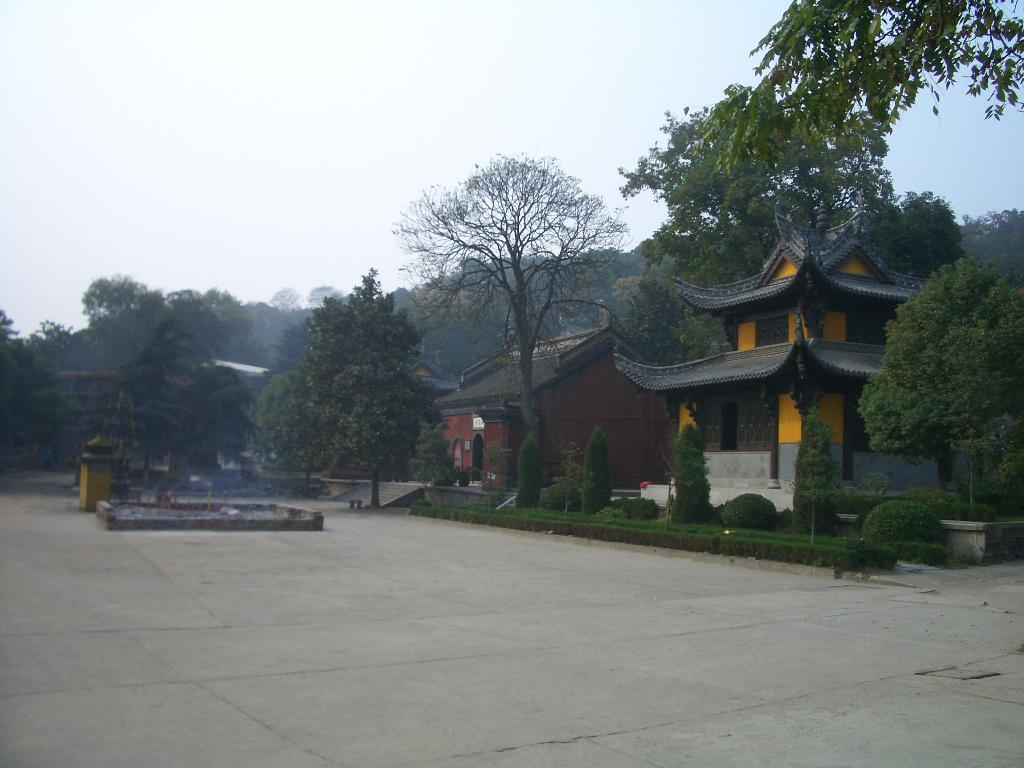What structures can be seen on the left side of the image? There are buildings on the left side of the image. What type of vegetation is present in the image? Trees and plants are visible in the image. How many boats can be seen sailing in the image? There are no boats present in the image. What type of cactus is growing among the plants in the image? There is no cactus present in the image; only trees and plants are visible. 